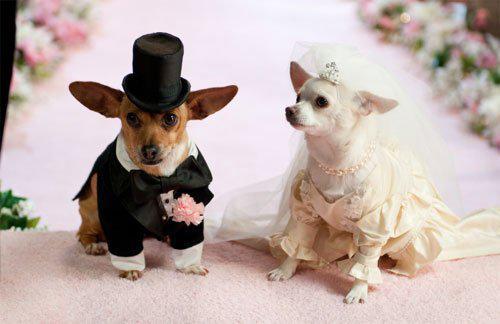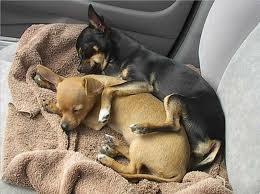The first image is the image on the left, the second image is the image on the right. Considering the images on both sides, is "At least one image shows two similarly colored chihuahuas." valid? Answer yes or no. No. The first image is the image on the left, the second image is the image on the right. Analyze the images presented: Is the assertion "Atleast one image contains both a brown and white chihuahua." valid? Answer yes or no. Yes. 